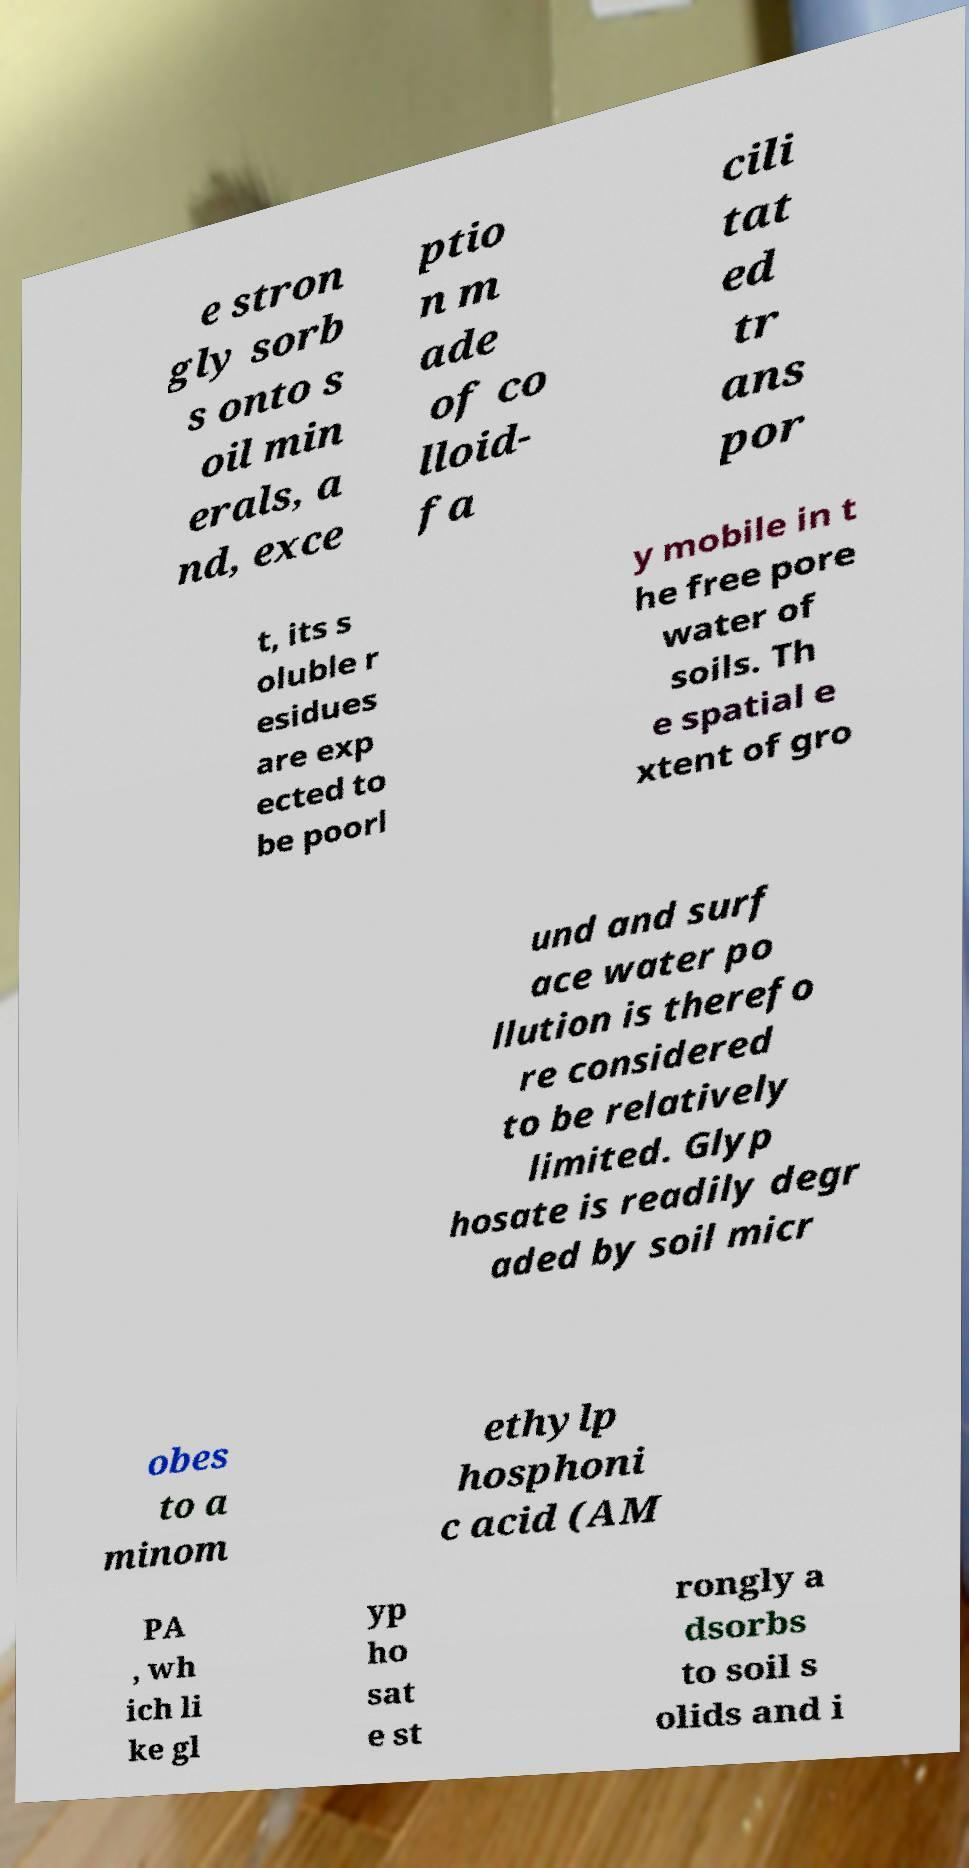Please identify and transcribe the text found in this image. e stron gly sorb s onto s oil min erals, a nd, exce ptio n m ade of co lloid- fa cili tat ed tr ans por t, its s oluble r esidues are exp ected to be poorl y mobile in t he free pore water of soils. Th e spatial e xtent of gro und and surf ace water po llution is therefo re considered to be relatively limited. Glyp hosate is readily degr aded by soil micr obes to a minom ethylp hosphoni c acid (AM PA , wh ich li ke gl yp ho sat e st rongly a dsorbs to soil s olids and i 